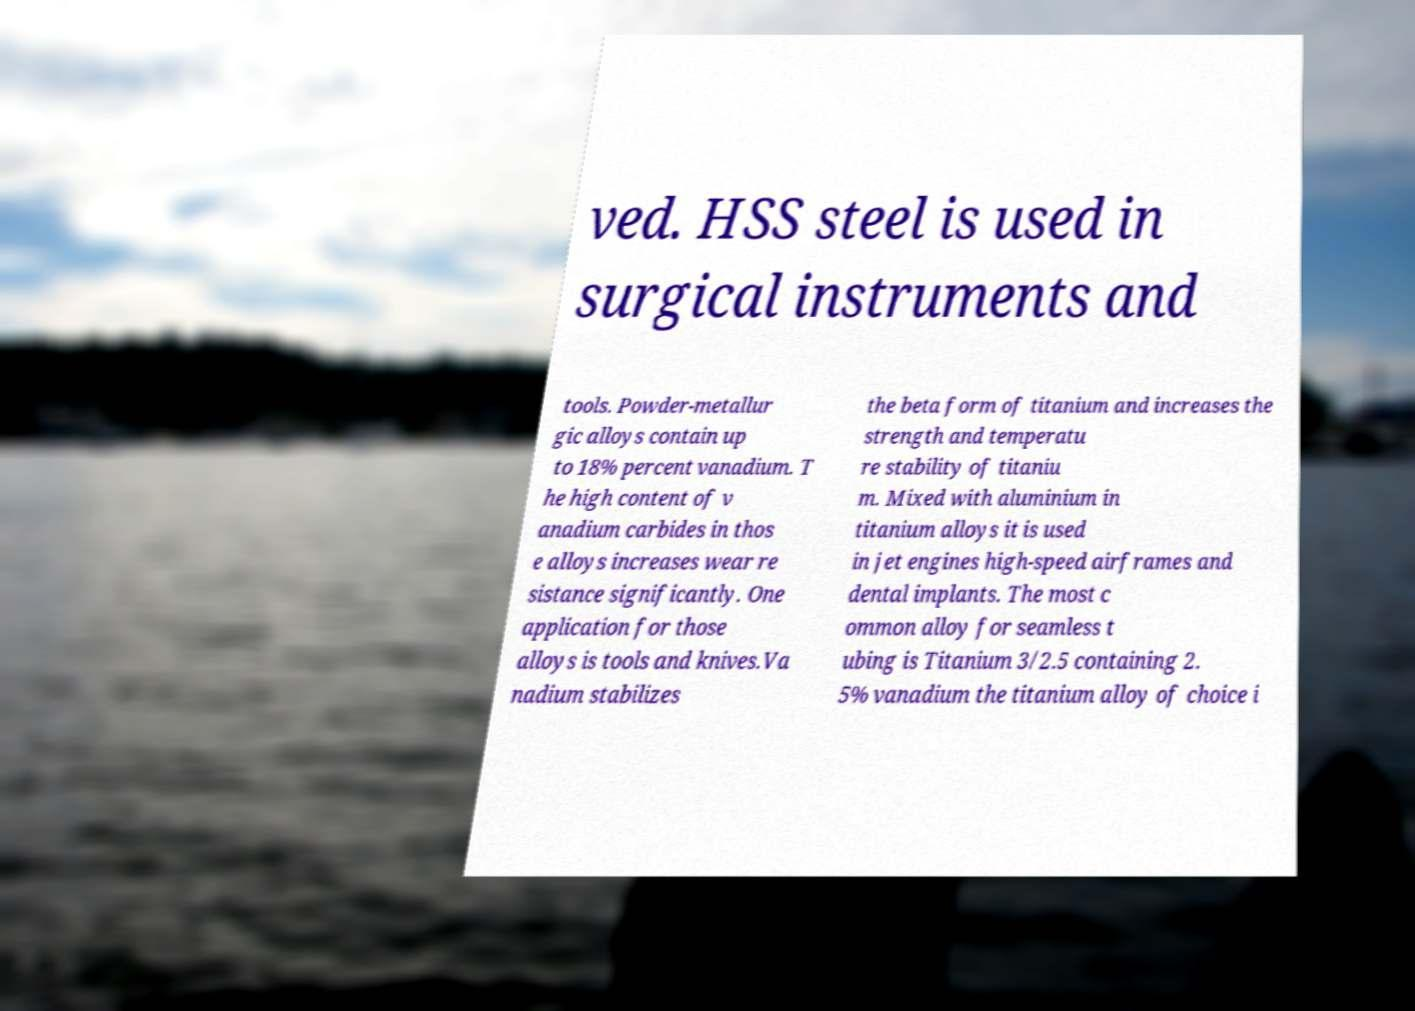Could you assist in decoding the text presented in this image and type it out clearly? ved. HSS steel is used in surgical instruments and tools. Powder-metallur gic alloys contain up to 18% percent vanadium. T he high content of v anadium carbides in thos e alloys increases wear re sistance significantly. One application for those alloys is tools and knives.Va nadium stabilizes the beta form of titanium and increases the strength and temperatu re stability of titaniu m. Mixed with aluminium in titanium alloys it is used in jet engines high-speed airframes and dental implants. The most c ommon alloy for seamless t ubing is Titanium 3/2.5 containing 2. 5% vanadium the titanium alloy of choice i 